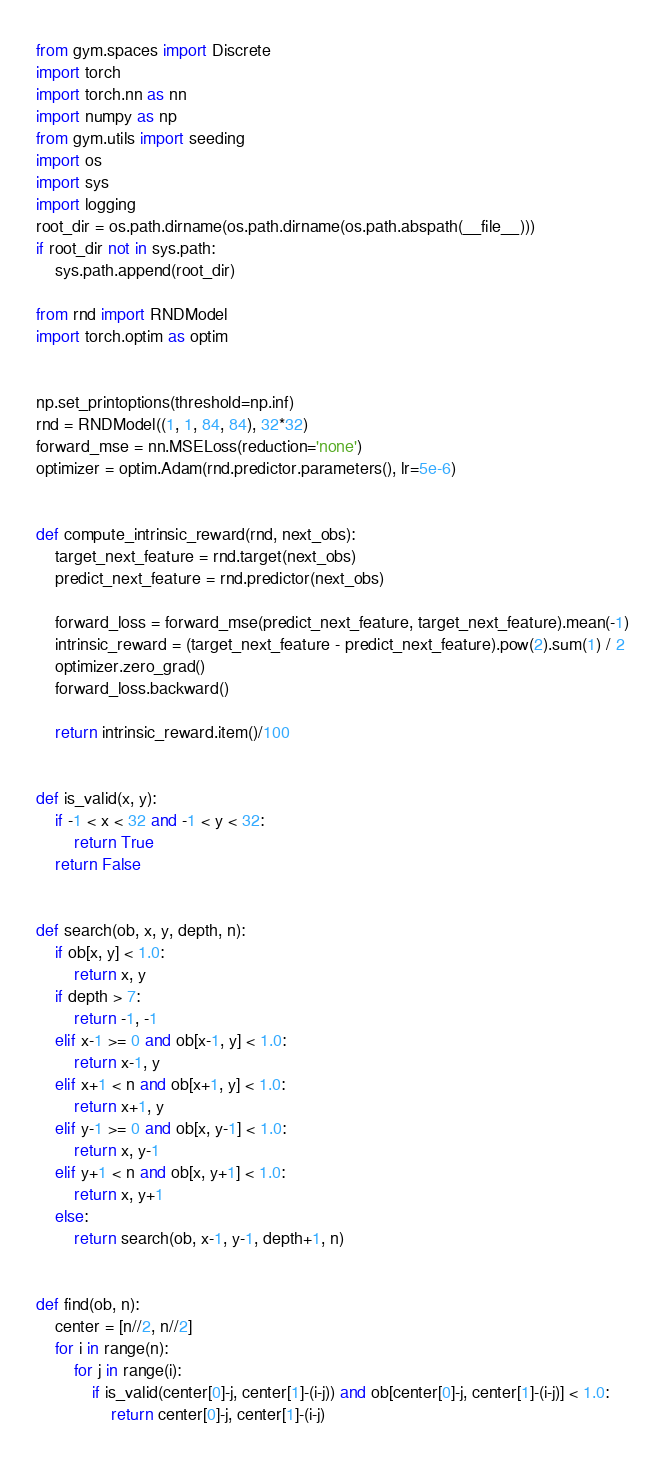Convert code to text. <code><loc_0><loc_0><loc_500><loc_500><_Python_>from gym.spaces import Discrete
import torch
import torch.nn as nn
import numpy as np
from gym.utils import seeding
import os
import sys
import logging
root_dir = os.path.dirname(os.path.dirname(os.path.abspath(__file__)))
if root_dir not in sys.path:
    sys.path.append(root_dir)

from rnd import RNDModel
import torch.optim as optim


np.set_printoptions(threshold=np.inf)
rnd = RNDModel((1, 1, 84, 84), 32*32)
forward_mse = nn.MSELoss(reduction='none')
optimizer = optim.Adam(rnd.predictor.parameters(), lr=5e-6)


def compute_intrinsic_reward(rnd, next_obs):
    target_next_feature = rnd.target(next_obs)
    predict_next_feature = rnd.predictor(next_obs)

    forward_loss = forward_mse(predict_next_feature, target_next_feature).mean(-1)
    intrinsic_reward = (target_next_feature - predict_next_feature).pow(2).sum(1) / 2
    optimizer.zero_grad()
    forward_loss.backward()

    return intrinsic_reward.item()/100


def is_valid(x, y):
    if -1 < x < 32 and -1 < y < 32:
        return True
    return False


def search(ob, x, y, depth, n):
    if ob[x, y] < 1.0:
        return x, y
    if depth > 7:
        return -1, -1
    elif x-1 >= 0 and ob[x-1, y] < 1.0:
        return x-1, y
    elif x+1 < n and ob[x+1, y] < 1.0:
        return x+1, y
    elif y-1 >= 0 and ob[x, y-1] < 1.0:
        return x, y-1
    elif y+1 < n and ob[x, y+1] < 1.0:
        return x, y+1
    else:
        return search(ob, x-1, y-1, depth+1, n)


def find(ob, n):
    center = [n//2, n//2]
    for i in range(n):
        for j in range(i):
            if is_valid(center[0]-j, center[1]-(i-j)) and ob[center[0]-j, center[1]-(i-j)] < 1.0:
                return center[0]-j, center[1]-(i-j)</code> 